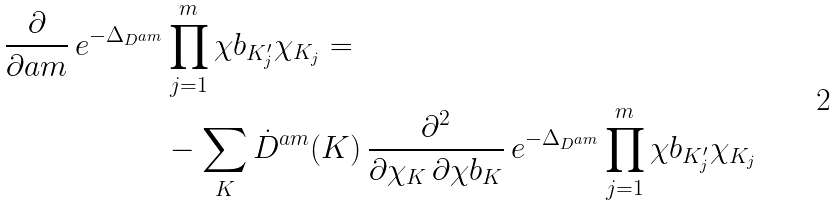Convert formula to latex. <formula><loc_0><loc_0><loc_500><loc_500>\frac { \partial } { \partial \L a m } \, e ^ { - \Delta _ { D ^ { \L a m } } } & \prod _ { j = 1 } ^ { m } \chi b _ { K ^ { \prime } _ { j } } \chi _ { K _ { j } } = \\ & - \sum _ { K } \dot { D } ^ { \L a m } ( K ) \, \frac { \partial ^ { 2 } } { \partial \chi _ { K } \, \partial \chi b _ { K } } \, e ^ { - \Delta _ { D ^ { \L a m } } } \prod _ { j = 1 } ^ { m } \chi b _ { K ^ { \prime } _ { j } } \chi _ { K _ { j } }</formula> 